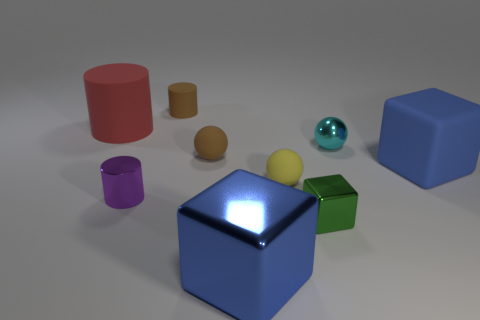Subtract all cubes. How many objects are left? 6 Subtract all rubber spheres. Subtract all cubes. How many objects are left? 4 Add 6 metal cubes. How many metal cubes are left? 8 Add 8 blue matte cylinders. How many blue matte cylinders exist? 8 Subtract 1 green blocks. How many objects are left? 8 